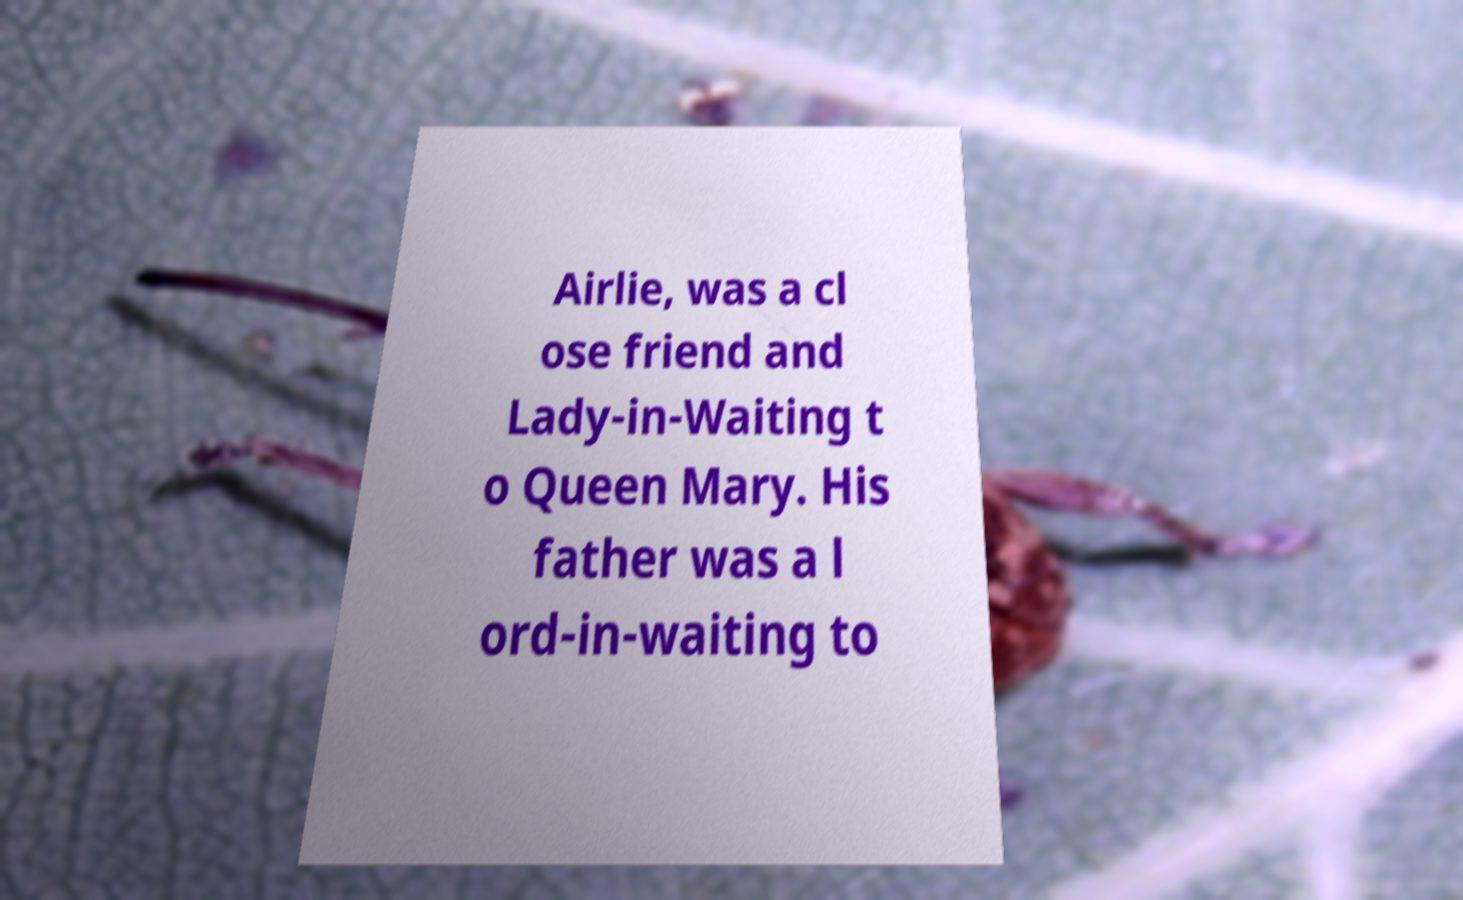Can you accurately transcribe the text from the provided image for me? Airlie, was a cl ose friend and Lady-in-Waiting t o Queen Mary. His father was a l ord-in-waiting to 